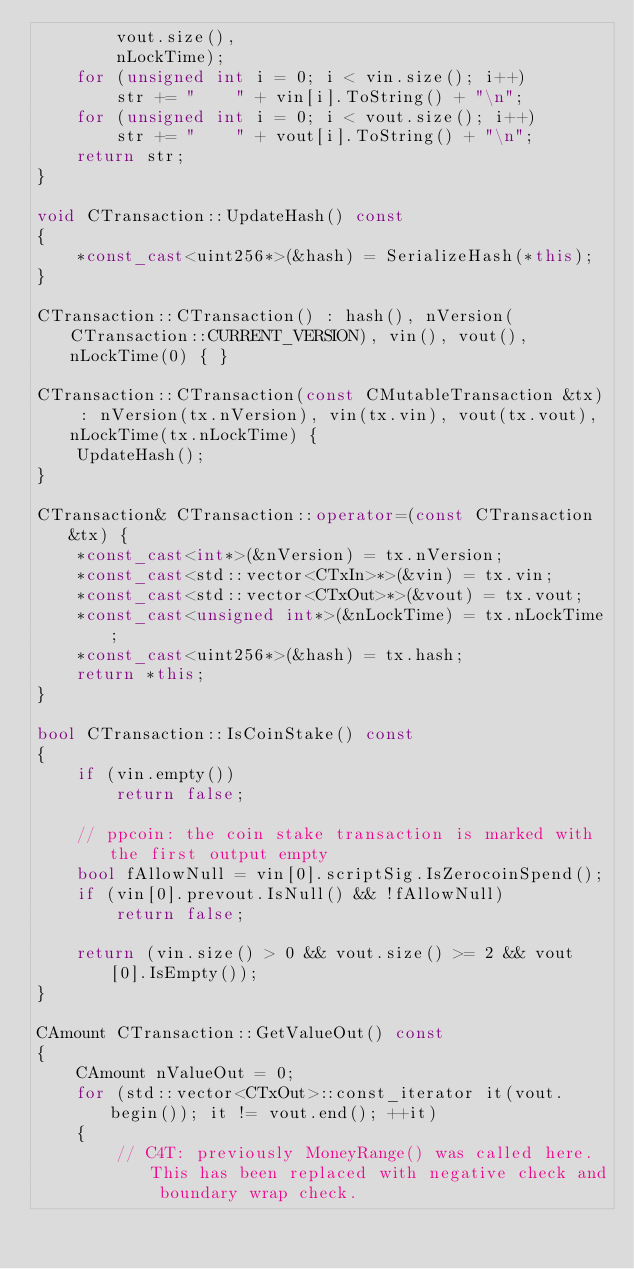<code> <loc_0><loc_0><loc_500><loc_500><_C++_>        vout.size(),
        nLockTime);
    for (unsigned int i = 0; i < vin.size(); i++)
        str += "    " + vin[i].ToString() + "\n";
    for (unsigned int i = 0; i < vout.size(); i++)
        str += "    " + vout[i].ToString() + "\n";
    return str;
}

void CTransaction::UpdateHash() const
{
    *const_cast<uint256*>(&hash) = SerializeHash(*this);
}

CTransaction::CTransaction() : hash(), nVersion(CTransaction::CURRENT_VERSION), vin(), vout(), nLockTime(0) { }

CTransaction::CTransaction(const CMutableTransaction &tx) : nVersion(tx.nVersion), vin(tx.vin), vout(tx.vout), nLockTime(tx.nLockTime) {
    UpdateHash();
}

CTransaction& CTransaction::operator=(const CTransaction &tx) {
    *const_cast<int*>(&nVersion) = tx.nVersion;
    *const_cast<std::vector<CTxIn>*>(&vin) = tx.vin;
    *const_cast<std::vector<CTxOut>*>(&vout) = tx.vout;
    *const_cast<unsigned int*>(&nLockTime) = tx.nLockTime;
    *const_cast<uint256*>(&hash) = tx.hash;
    return *this;
}

bool CTransaction::IsCoinStake() const
{
    if (vin.empty())
        return false;

    // ppcoin: the coin stake transaction is marked with the first output empty
    bool fAllowNull = vin[0].scriptSig.IsZerocoinSpend();
    if (vin[0].prevout.IsNull() && !fAllowNull)
        return false;

    return (vin.size() > 0 && vout.size() >= 2 && vout[0].IsEmpty());
}

CAmount CTransaction::GetValueOut() const
{
    CAmount nValueOut = 0;
    for (std::vector<CTxOut>::const_iterator it(vout.begin()); it != vout.end(); ++it)
    {
        // C4T: previously MoneyRange() was called here. This has been replaced with negative check and boundary wrap check.</code> 